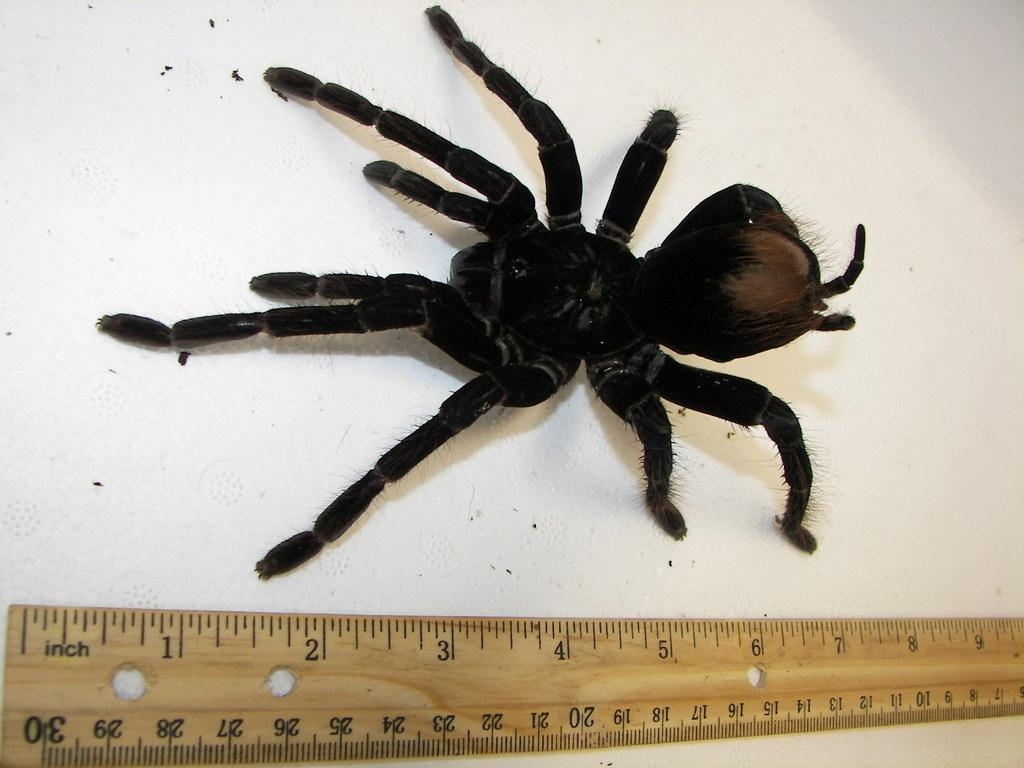What type of animal is present in the image? There is a spider in the image. What object can be used to measure weight in the image? There is a scale in the image. Can you tell me how many zephyrs are present in the image? There are no zephyrs present in the image, as a zephyr is a gentle breeze and not a physical object that can be seen. 